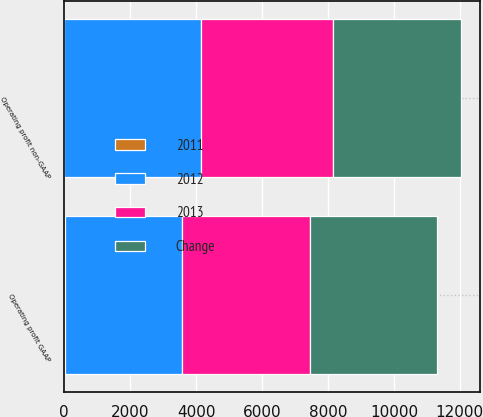Convert chart. <chart><loc_0><loc_0><loc_500><loc_500><stacked_bar_chart><ecel><fcel>Operating profit GAAP<fcel>Operating profit non-GAAP<nl><fcel>2012<fcel>3556<fcel>4140<nl><fcel>2013<fcel>3889<fcel>4023<nl><fcel>2011<fcel>9<fcel>3<nl><fcel>Change<fcel>3841<fcel>3858<nl></chart> 